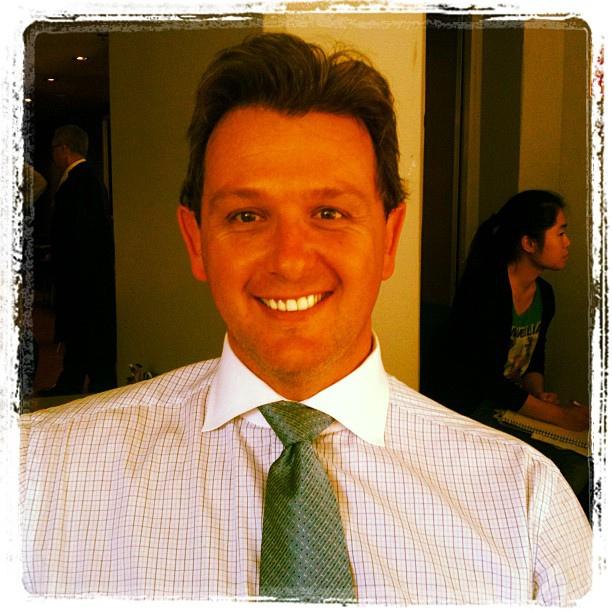The yellow in this snapshot makes one think of what sour-tasting, potentially burning compound?
Concise answer only. Sulfur. What color t-shirt is on the girl in the background?
Concise answer only. Green. Is the guy's teeth real?
Concise answer only. Yes. 